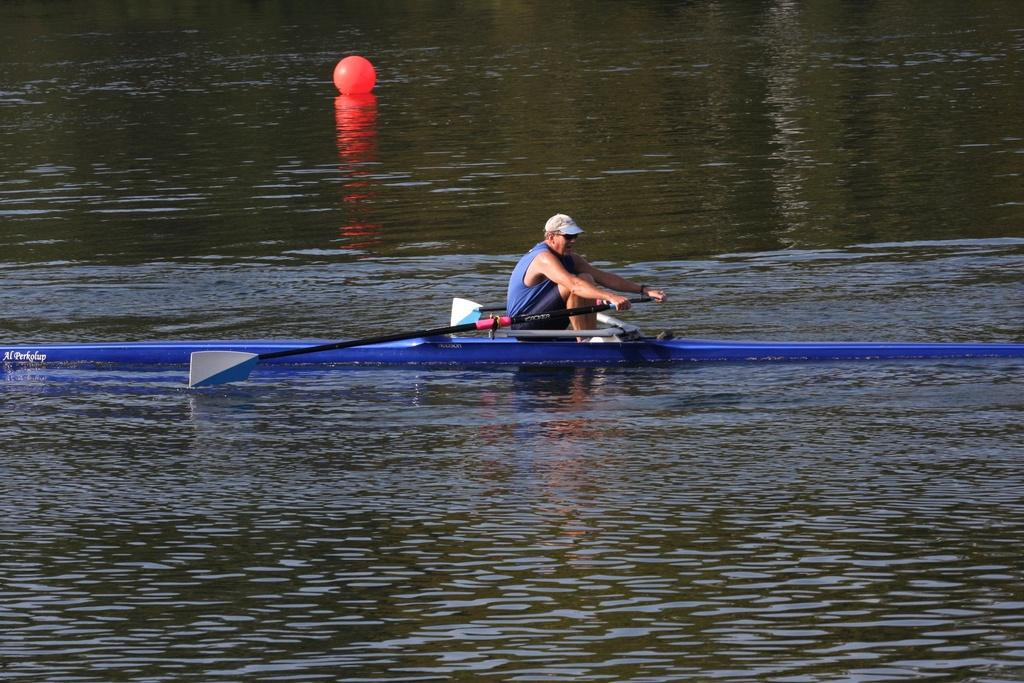What is the person in the image doing? The person is sailing a boat in the image. Where is the boat located? The boat is on the water. What else is visible near the person in the image? There is a ball beside the person. What type of oven is visible in the image? There is no oven present in the image. How many points does the car have in the image? There is no car present in the image. 